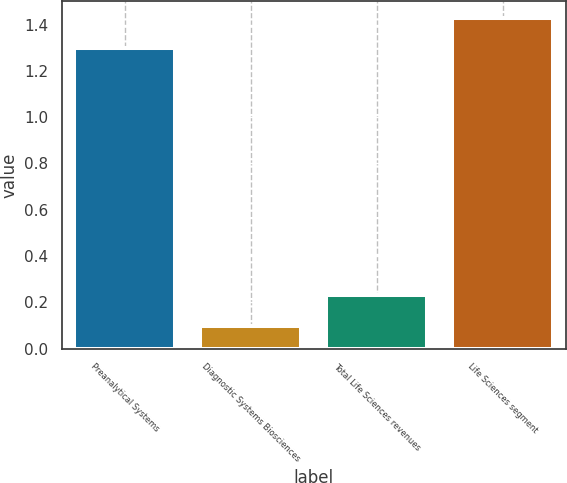Convert chart. <chart><loc_0><loc_0><loc_500><loc_500><bar_chart><fcel>Preanalytical Systems<fcel>Diagnostic Systems Biosciences<fcel>Total Life Sciences revenues<fcel>Life Sciences segment<nl><fcel>1.3<fcel>0.1<fcel>0.23<fcel>1.43<nl></chart> 